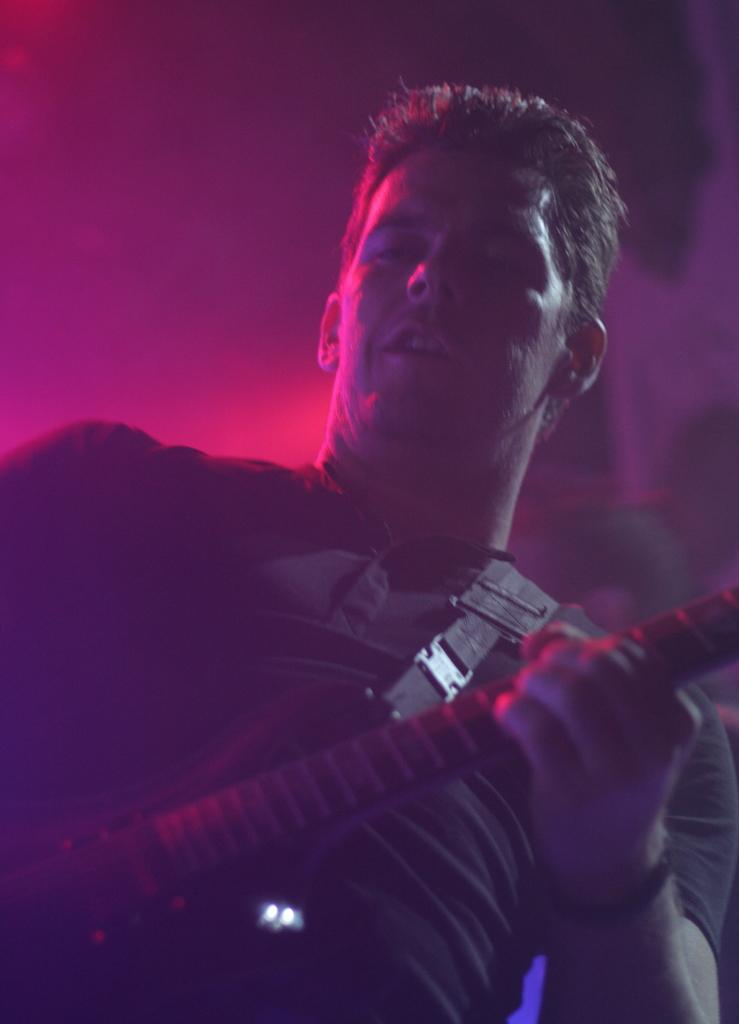What is the main subject of the image? There is a person in the image. What is the person wearing? The person is wearing a black dress. What is the person holding in the image? The person is holding a guitar. What color is the background of the image? The background of the image is in pink color. Can you see a train passing by in the background of the image? No, there is no train present in the image. 